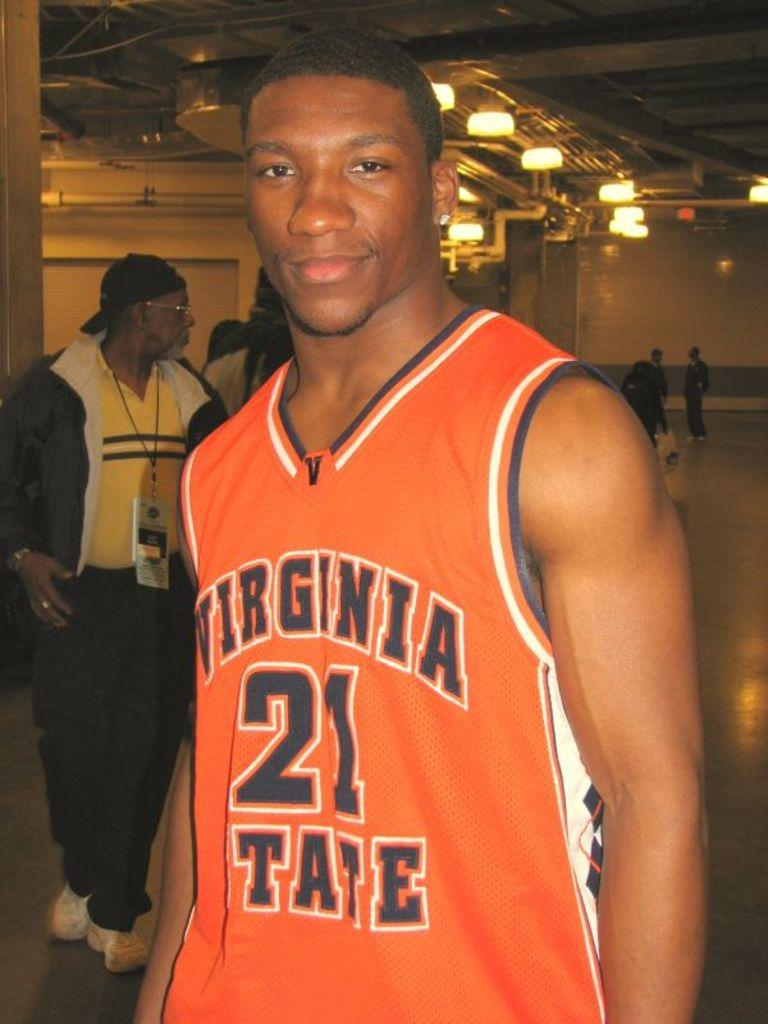<image>
Relay a brief, clear account of the picture shown. a player that has a Virginia jersey on their backs 